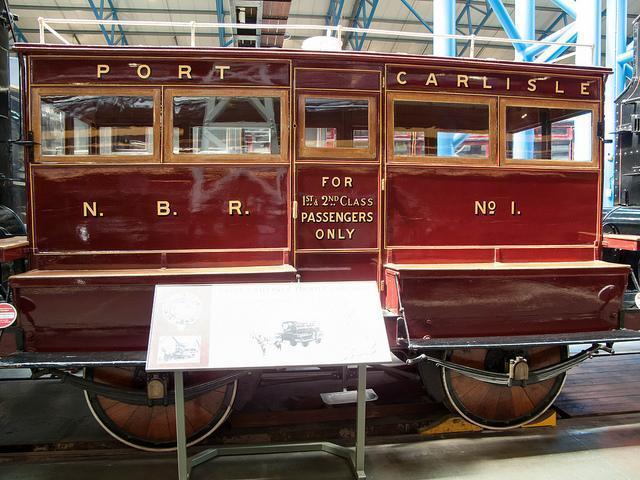How many people do you see?
Give a very brief answer. 0. 